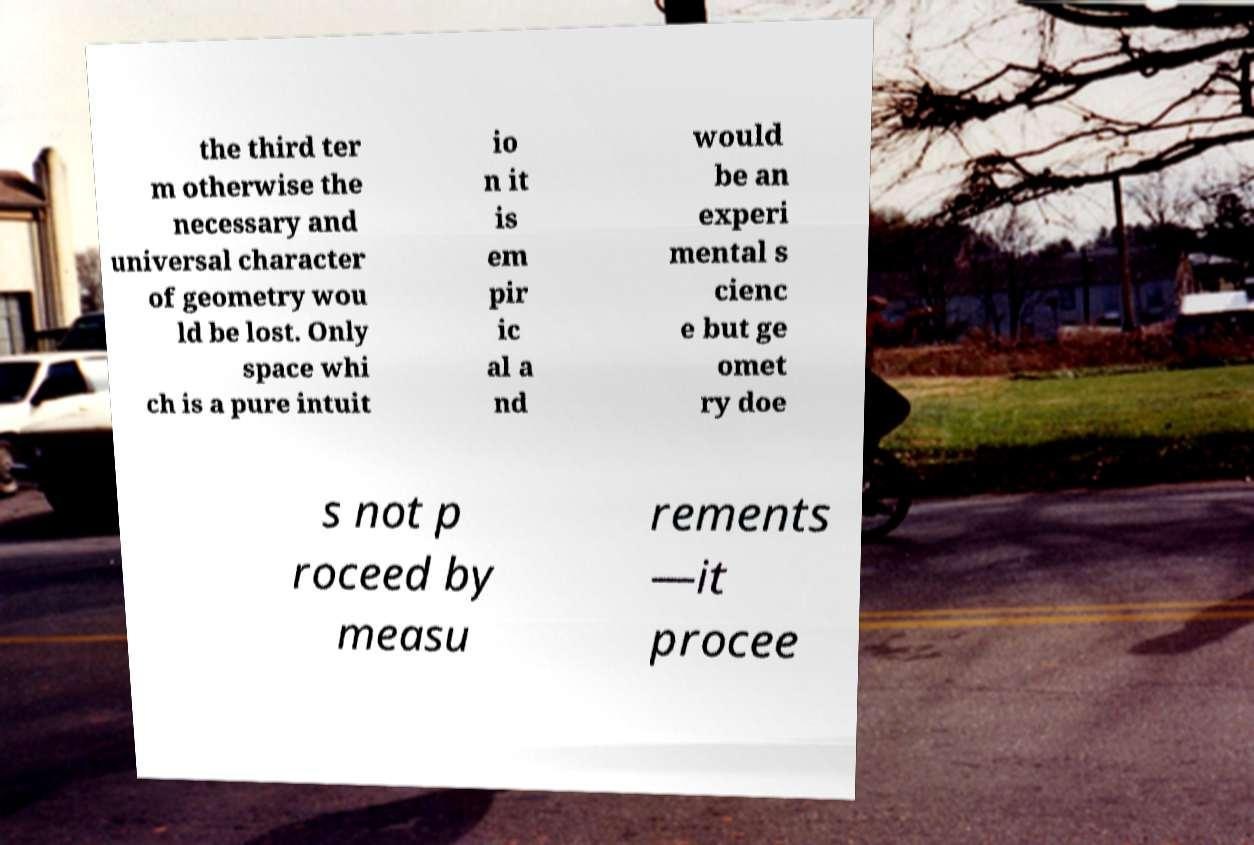There's text embedded in this image that I need extracted. Can you transcribe it verbatim? the third ter m otherwise the necessary and universal character of geometry wou ld be lost. Only space whi ch is a pure intuit io n it is em pir ic al a nd would be an experi mental s cienc e but ge omet ry doe s not p roceed by measu rements —it procee 